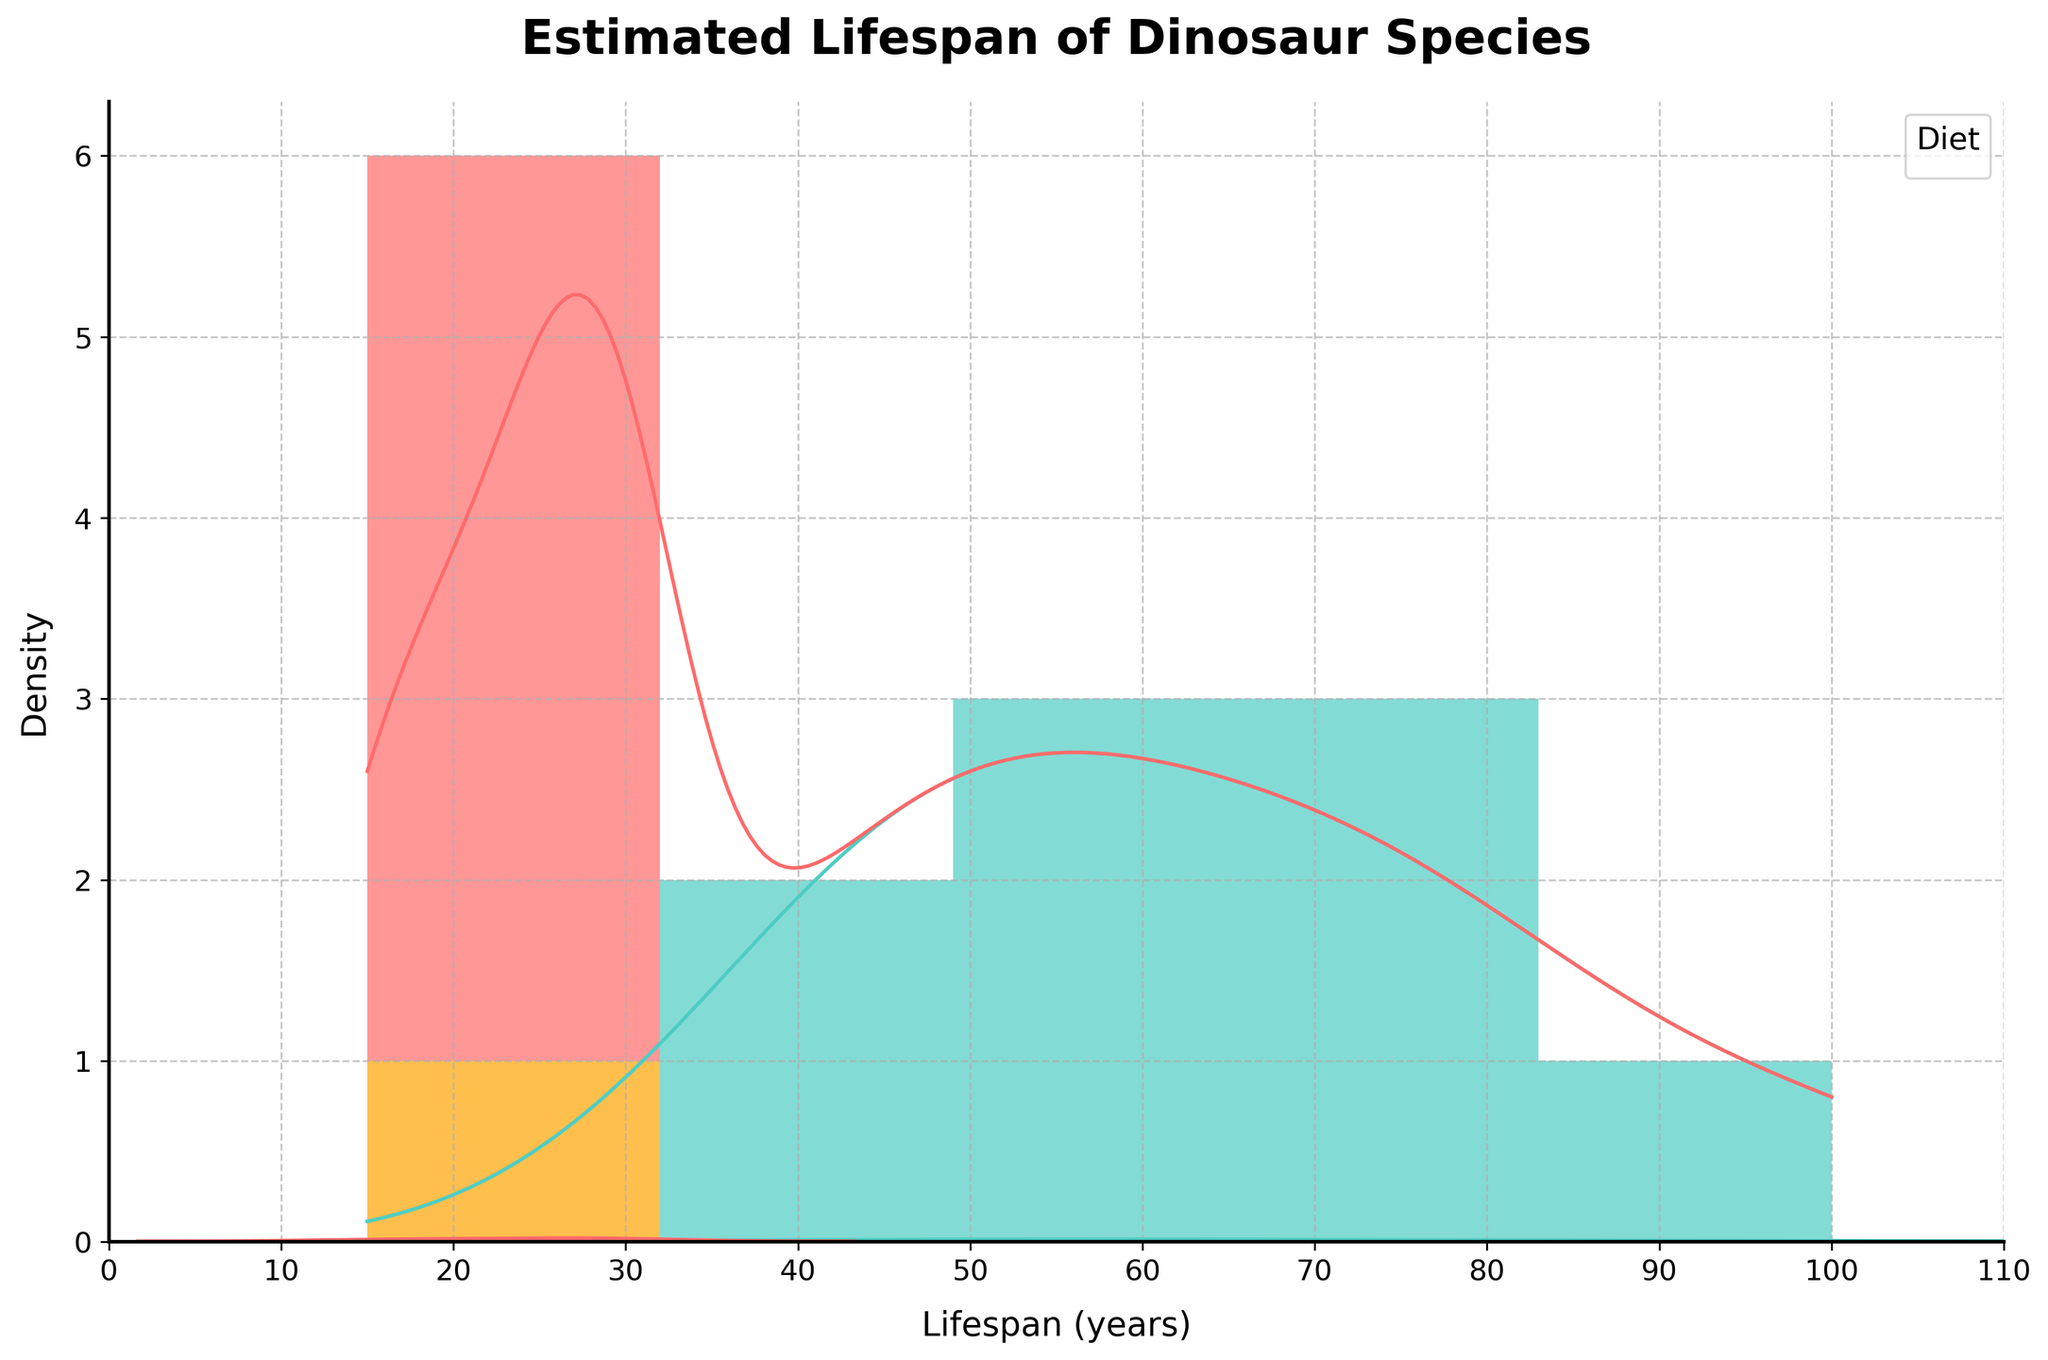What is the title of the plot? The title is typically displayed at the top of the plot. Here, it is clearly labeled "Estimated Lifespan of Dinosaur Species."
Answer: Estimated Lifespan of Dinosaur Species What does the x-axis represent? The x-axis typically represents the variable being measured or compared. In this case, it shows the lifespan of the dinosaur species in years.
Answer: Lifespan (years) How many dietary categories are plotted, and what are they? By observing the legend and the color differentiation in the histogram and KDE plot, we can see that there are three dietary categories: "Carnivore" in red, "Herbivore" in green, and "Omnivore" in orange.
Answer: Three: Carnivore, Herbivore, Omnivore Which dietary group appears to have the longest estimated lifespan? By looking at the density peaks and the spread of the data on the x-axis, we can see that "Herbivores" (green) have lifespans that go as high as 100 years.
Answer: Herbivores For which dietary group is the lifespan distribution more spread out? By comparing the spreads of the density curves, you can see that "Herbivores" (green) have a wide range extending from 40 to 100 years, indicating a more spread-out distribution.
Answer: Herbivores What is the range of lifespans for carnivores? By observing the red density curve and histogram bars, we see that the lifespans for carnivores range from approximately 15 to 30 years.
Answer: 15 to 30 years Which dietary group has the highest density peak in the KDE plot? Observing the height of the density curves, the "Herbivores" (green) have the highest peak, suggesting most individuals in this group have similar lifespans.
Answer: Herbivores What is the visual difference between the histogram bars and the KDE curves? The histogram bars show the count of dinosaur species in each bin, while the KDE curves provide a smoothed estimate of the probability density of lifespans for each dietary group.
Answer: Histogram bars vs. KDE curves Which herbivore has the longest estimated lifespan, and what is that lifespan? From the dataset, Brachiosaurus is the herbivore with the longest lifespan at 100 years. The KDE peak also supports this data point.
Answer: Brachiosaurus: 100 years How does the lifespan of omnivores compare to that of herbivores and carnivores? By comparing the KDE and histogram, omnivores (in orange) show a narrower range of lifespan around 18 years, shorter than both herbivores (40 to 100 years) and carnivores (15 to 30 years).
Answer: Shorter lifespan than both herbivores and carnivores 